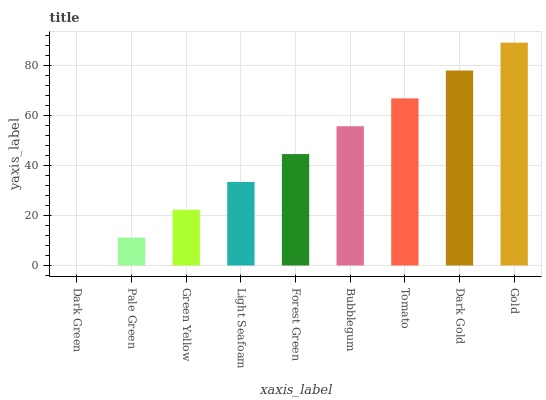Is Pale Green the minimum?
Answer yes or no. No. Is Pale Green the maximum?
Answer yes or no. No. Is Pale Green greater than Dark Green?
Answer yes or no. Yes. Is Dark Green less than Pale Green?
Answer yes or no. Yes. Is Dark Green greater than Pale Green?
Answer yes or no. No. Is Pale Green less than Dark Green?
Answer yes or no. No. Is Forest Green the high median?
Answer yes or no. Yes. Is Forest Green the low median?
Answer yes or no. Yes. Is Tomato the high median?
Answer yes or no. No. Is Tomato the low median?
Answer yes or no. No. 